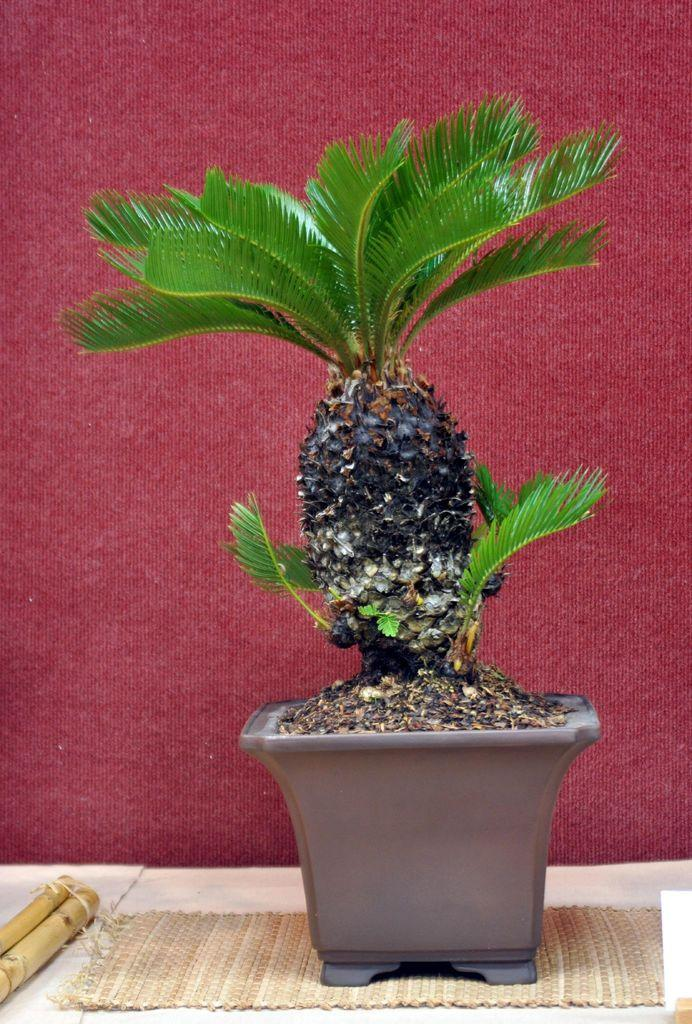What type of plant is in the image? There is a plant on a flower pot in the image. What is located near the plant? There is a doormat in the image. What other objects can be seen in the image? There are wooden sticks in the image. What color is the wall in the background of the image? There is a maroon color wall in the background of the image. How many eyes can be seen on the plant in the image? Plants do not have eyes, so there are no eyes visible on the plant in the image. 